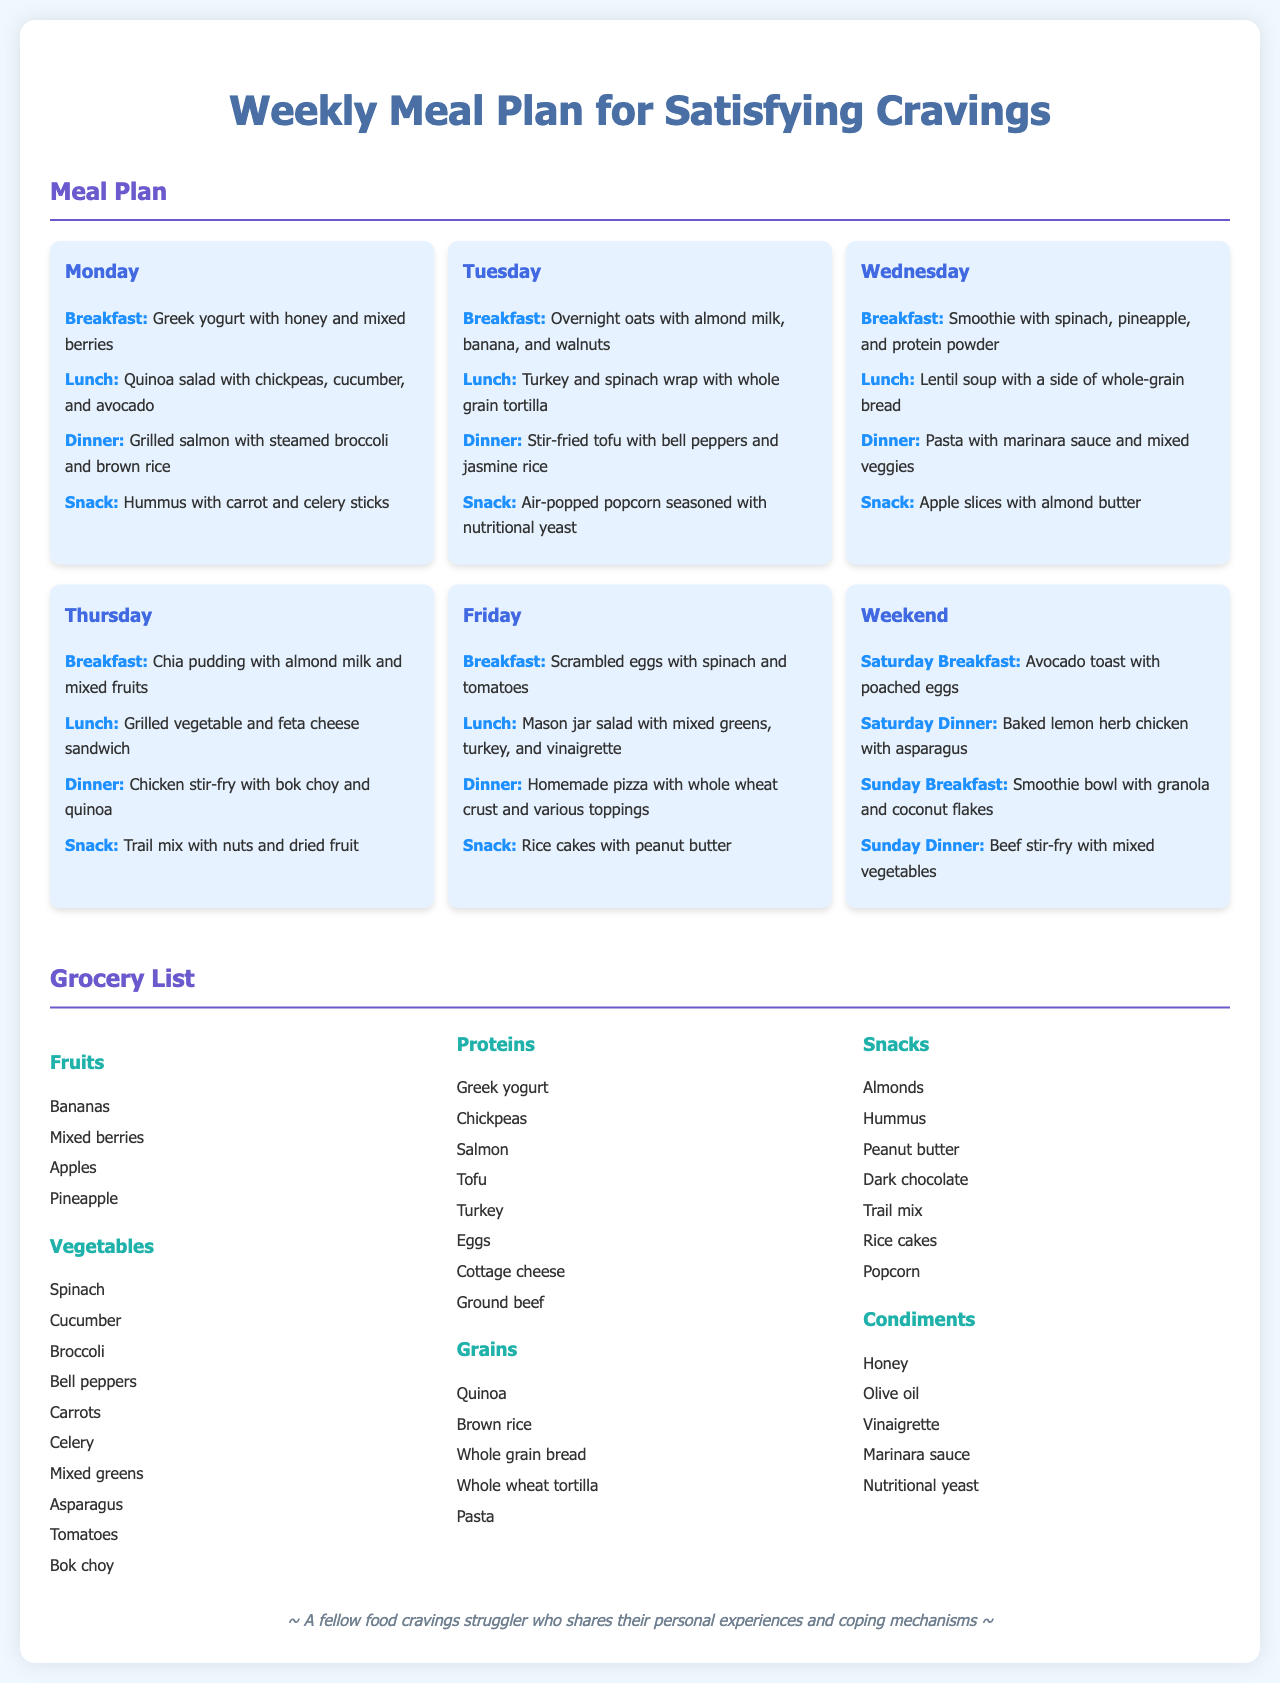What is the first breakfast listed in the meal plan? The first breakfast listed in the meal plan is Greek yogurt with honey and mixed berries for Monday.
Answer: Greek yogurt with honey and mixed berries How many meals are listed for the weekend? There are four meals listed for the weekend, two for Saturday and two for Sunday.
Answer: 4 What protein is included in the Tuesday dinner? The protein included in the Tuesday dinner is tofu.
Answer: Tofu Which snack is paired with Monday's dinner? The snack paired with Monday's dinner is hummus with carrot and celery sticks.
Answer: Hummus with carrot and celery sticks List one condiment mentioned in the grocery list. One condiment mentioned in the grocery list is honey.
Answer: Honey Which vegetable is mentioned under the grocery list? Cucumber is one of the vegetables mentioned under the grocery list.
Answer: Cucumber What type of bread is used in the grilled vegetable and feta cheese sandwich? The type of bread used is whole grain bread.
Answer: Whole grain bread What ingredient is repeated for breakfast on both Sunday and Saturday? Avocado toast with poached eggs is listed for Saturday breakfast and a smoothie bowl for Sunday breakfast.
Answer: Avocado toast with poached eggs How many snacks are listed in the grocery list? There are seven snacks listed in the grocery list.
Answer: 7 What is the title of the document? The title of the document is "Weekly Meal Plan for Satisfying Cravings."
Answer: Weekly Meal Plan for Satisfying Cravings 